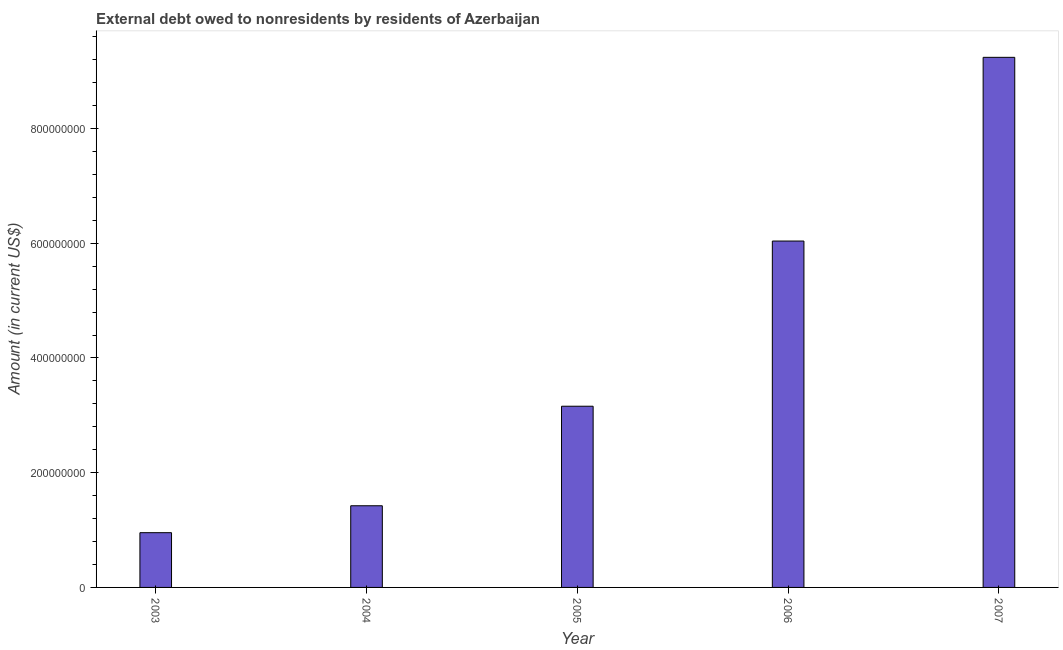What is the title of the graph?
Your answer should be compact. External debt owed to nonresidents by residents of Azerbaijan. What is the label or title of the X-axis?
Give a very brief answer. Year. What is the debt in 2005?
Ensure brevity in your answer.  3.16e+08. Across all years, what is the maximum debt?
Provide a short and direct response. 9.24e+08. Across all years, what is the minimum debt?
Your response must be concise. 9.54e+07. In which year was the debt maximum?
Provide a short and direct response. 2007. In which year was the debt minimum?
Offer a very short reply. 2003. What is the sum of the debt?
Ensure brevity in your answer.  2.08e+09. What is the difference between the debt in 2005 and 2006?
Offer a terse response. -2.88e+08. What is the average debt per year?
Keep it short and to the point. 4.16e+08. What is the median debt?
Provide a short and direct response. 3.16e+08. In how many years, is the debt greater than 440000000 US$?
Offer a terse response. 2. Do a majority of the years between 2006 and 2007 (inclusive) have debt greater than 920000000 US$?
Offer a very short reply. No. What is the ratio of the debt in 2003 to that in 2007?
Keep it short and to the point. 0.1. What is the difference between the highest and the second highest debt?
Ensure brevity in your answer.  3.20e+08. Is the sum of the debt in 2005 and 2007 greater than the maximum debt across all years?
Keep it short and to the point. Yes. What is the difference between the highest and the lowest debt?
Offer a very short reply. 8.29e+08. How many years are there in the graph?
Provide a succinct answer. 5. What is the difference between two consecutive major ticks on the Y-axis?
Give a very brief answer. 2.00e+08. What is the Amount (in current US$) of 2003?
Give a very brief answer. 9.54e+07. What is the Amount (in current US$) of 2004?
Your answer should be very brief. 1.42e+08. What is the Amount (in current US$) of 2005?
Your response must be concise. 3.16e+08. What is the Amount (in current US$) in 2006?
Provide a succinct answer. 6.04e+08. What is the Amount (in current US$) in 2007?
Your answer should be compact. 9.24e+08. What is the difference between the Amount (in current US$) in 2003 and 2004?
Provide a short and direct response. -4.69e+07. What is the difference between the Amount (in current US$) in 2003 and 2005?
Offer a terse response. -2.20e+08. What is the difference between the Amount (in current US$) in 2003 and 2006?
Offer a very short reply. -5.08e+08. What is the difference between the Amount (in current US$) in 2003 and 2007?
Your answer should be compact. -8.29e+08. What is the difference between the Amount (in current US$) in 2004 and 2005?
Keep it short and to the point. -1.73e+08. What is the difference between the Amount (in current US$) in 2004 and 2006?
Make the answer very short. -4.61e+08. What is the difference between the Amount (in current US$) in 2004 and 2007?
Provide a short and direct response. -7.82e+08. What is the difference between the Amount (in current US$) in 2005 and 2006?
Keep it short and to the point. -2.88e+08. What is the difference between the Amount (in current US$) in 2005 and 2007?
Your response must be concise. -6.08e+08. What is the difference between the Amount (in current US$) in 2006 and 2007?
Your response must be concise. -3.20e+08. What is the ratio of the Amount (in current US$) in 2003 to that in 2004?
Offer a terse response. 0.67. What is the ratio of the Amount (in current US$) in 2003 to that in 2005?
Give a very brief answer. 0.3. What is the ratio of the Amount (in current US$) in 2003 to that in 2006?
Give a very brief answer. 0.16. What is the ratio of the Amount (in current US$) in 2003 to that in 2007?
Provide a short and direct response. 0.1. What is the ratio of the Amount (in current US$) in 2004 to that in 2005?
Ensure brevity in your answer.  0.45. What is the ratio of the Amount (in current US$) in 2004 to that in 2006?
Your answer should be compact. 0.24. What is the ratio of the Amount (in current US$) in 2004 to that in 2007?
Keep it short and to the point. 0.15. What is the ratio of the Amount (in current US$) in 2005 to that in 2006?
Provide a succinct answer. 0.52. What is the ratio of the Amount (in current US$) in 2005 to that in 2007?
Offer a terse response. 0.34. What is the ratio of the Amount (in current US$) in 2006 to that in 2007?
Your response must be concise. 0.65. 